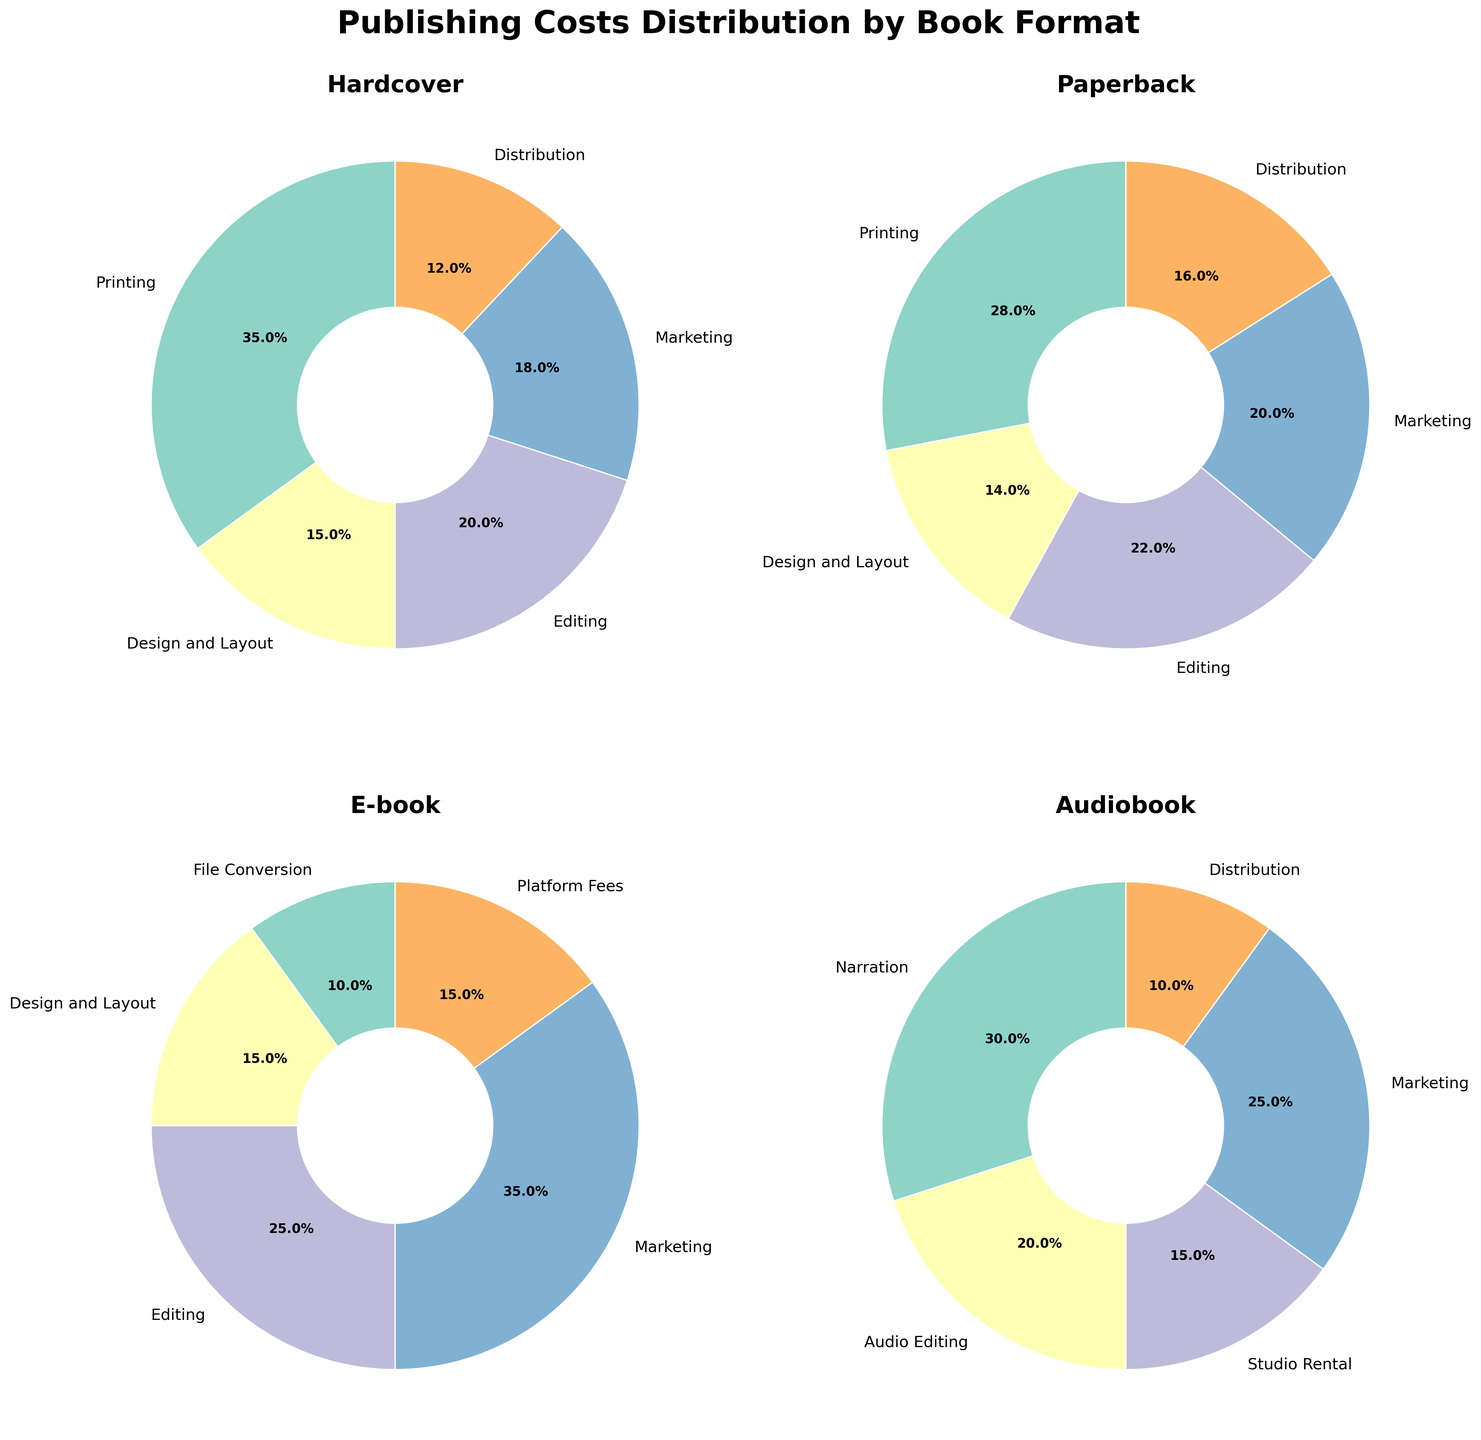Which format has the highest percentage spent on Marketing? By examining each pie chart's slices labeled "Marketing" and their associated percentages, it's clear that the 'E-book' format has the highest marketing expenditure at 35%.
Answer: E-book What is the total percentage spent on Printing for Hardcover and Paperback formats combined? Summing the Printing percentages from the Hardcover (35%) and Paperback (28%) segments gives 35 + 28 = 63%.
Answer: 63% Which publishing format spends the least percentage on Distribution? By comparing the Distribution percentages across all formats: Hardcover (12%), Paperback (16%), E-book (15%), and Audiobook (10%), the Audiobook format has the lowest spending at 10%.
Answer: Audiobook Which cost category has the highest percentage for Audiobooks, and what is the percentage? By looking at the Audiobook pie chart, the "Narration" category occupies the largest slice, labeled with 30%.
Answer: Narration, 30% Compare the percentage spent on Editing between Paperback and E-book formats. Which one is higher, and by how much? Paperback Editing is 22%, and E-book Editing is 25%. The difference is 25 - 22 = 3%.
Answer: E-book, 3% For the Hardcover format, identify the cost category with the smallest percentage and state the percentage. The smallest slice on the Hardcover pie chart is "Distribution," labeled with 12%.
Answer: Distribution, 12% Which format has the highest number of cost categories with percentages above 20%? By counting the categories above 20%: Hardcover (2 categories: Editing and Printing), Paperback (3 categories: Editing, Marketing, Printing), E-book (2 categories: Editing and Marketing), Audiobook (2 categories: Narration and Marketing). The Paperback format has the most with 3 such categories.
Answer: Paperback Calculate the difference in percentage spent on Design and Layout between Hardcover and E-book formats. The percentage for Design and Layout is 15% for both Hardcover and E-book, so the difference is 0%.
Answer: 0% What is the percentage spent on non-marketing costs for E-books? Summing non-marketing percentages for E-books (File Conversion 10% + Design and Layout 15% + Editing 25% + Platform Fees 15%) gives 10 + 15 + 25 + 15 = 65%.
Answer: 65% How much more percentage does Audiobook spend on Marketing compared to its Distribution? Audiobook Marketing is 25%, and Distribution is 10%. The difference is 25 - 10 = 15%.
Answer: 15% 